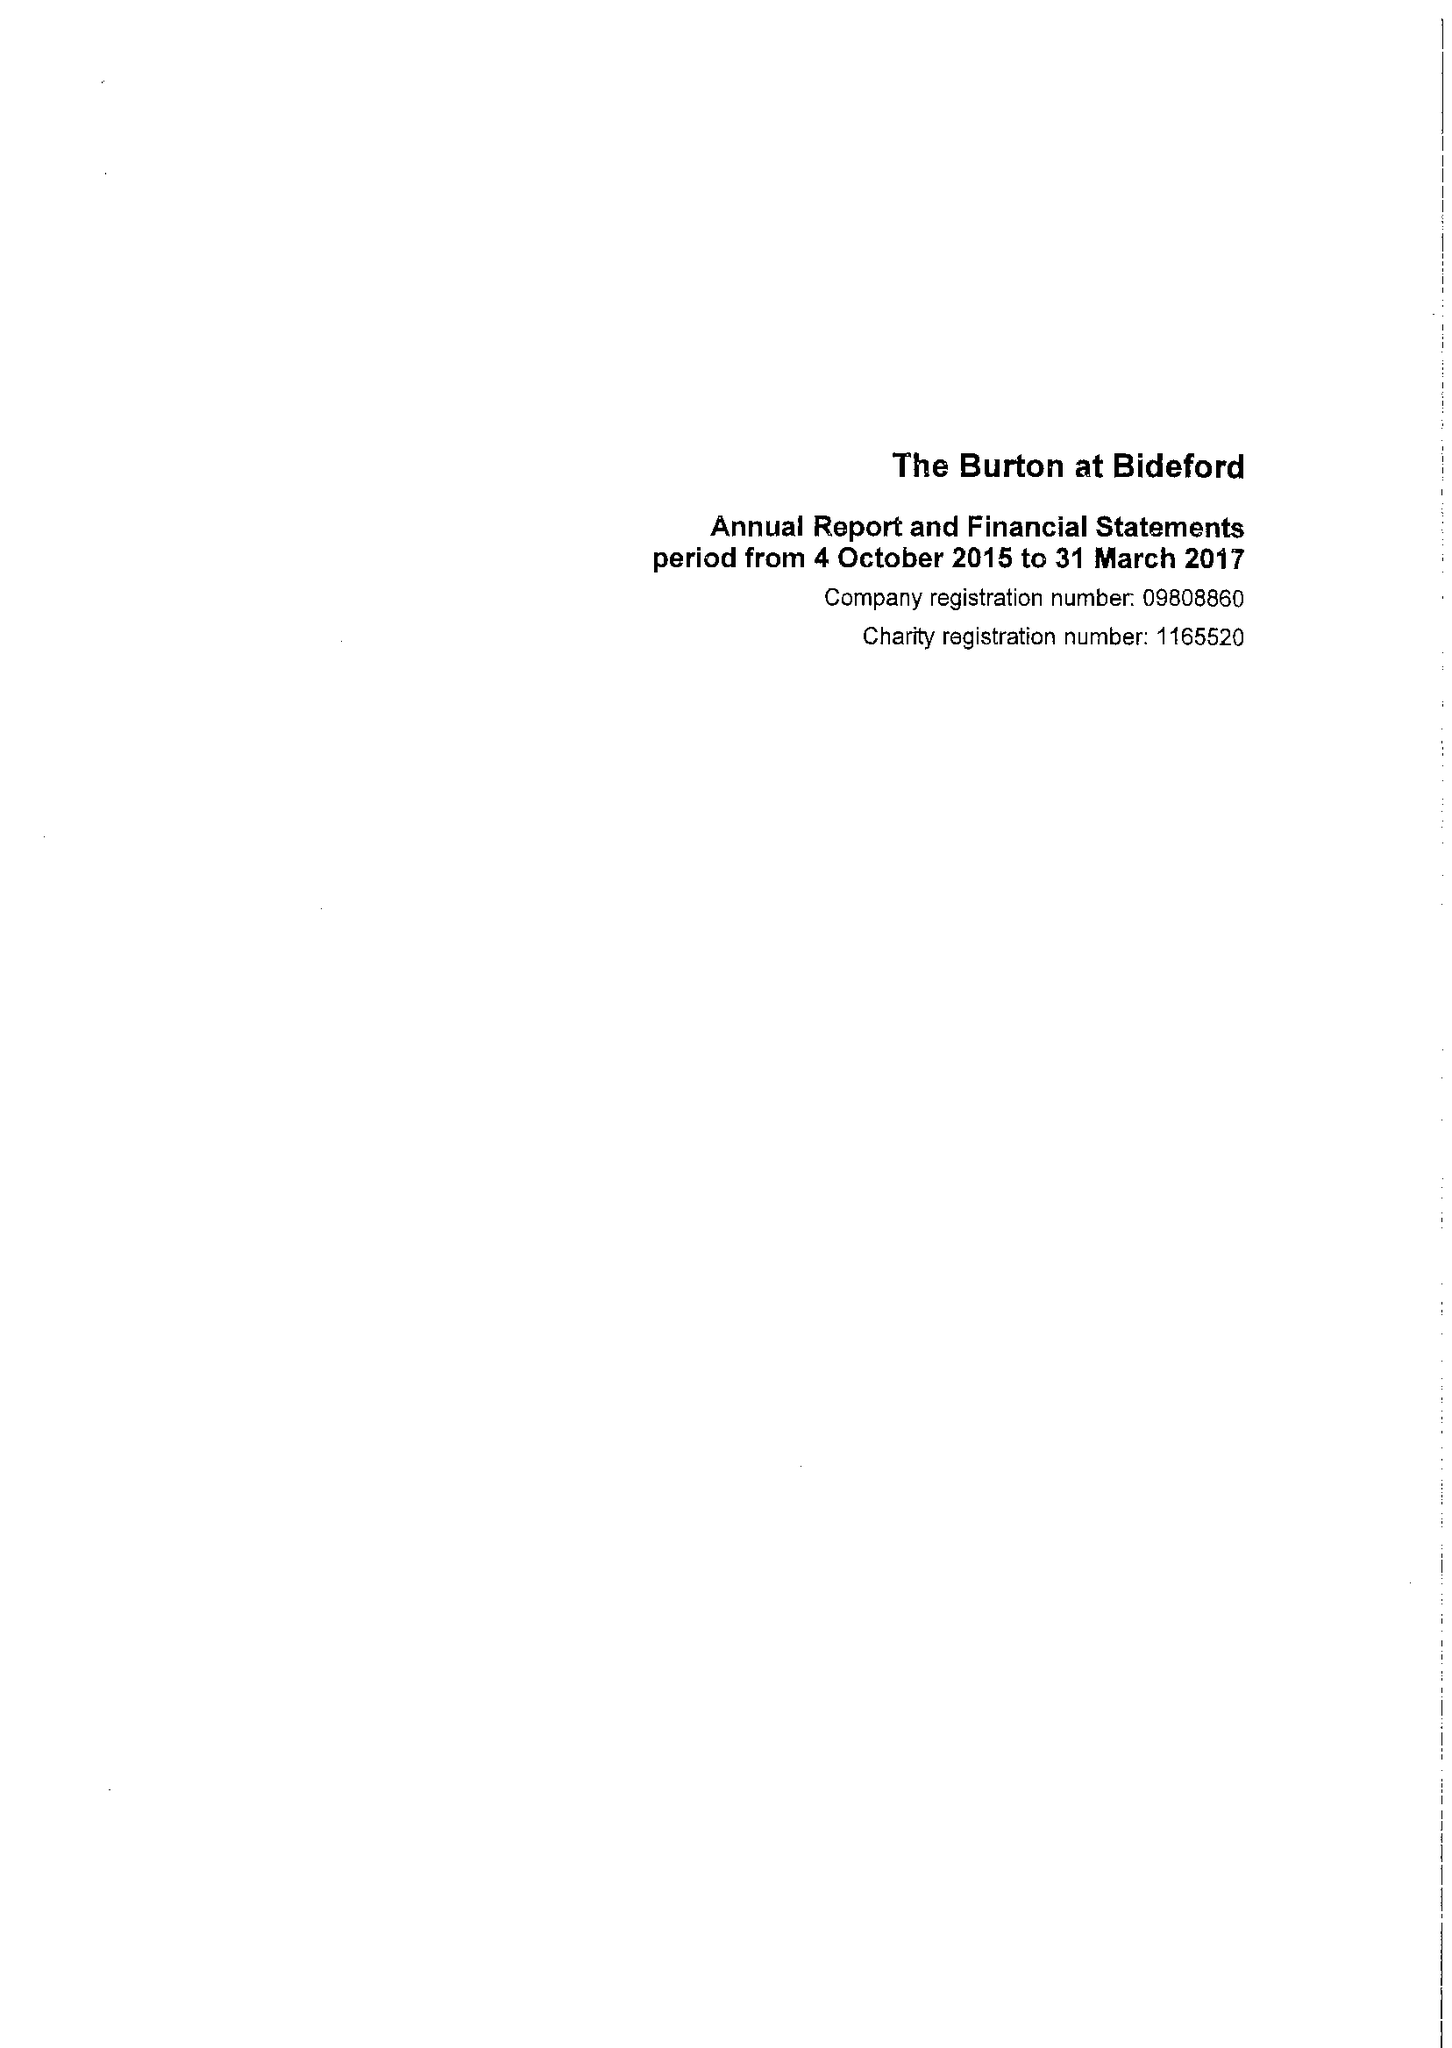What is the value for the income_annually_in_british_pounds?
Answer the question using a single word or phrase. 359020.00 